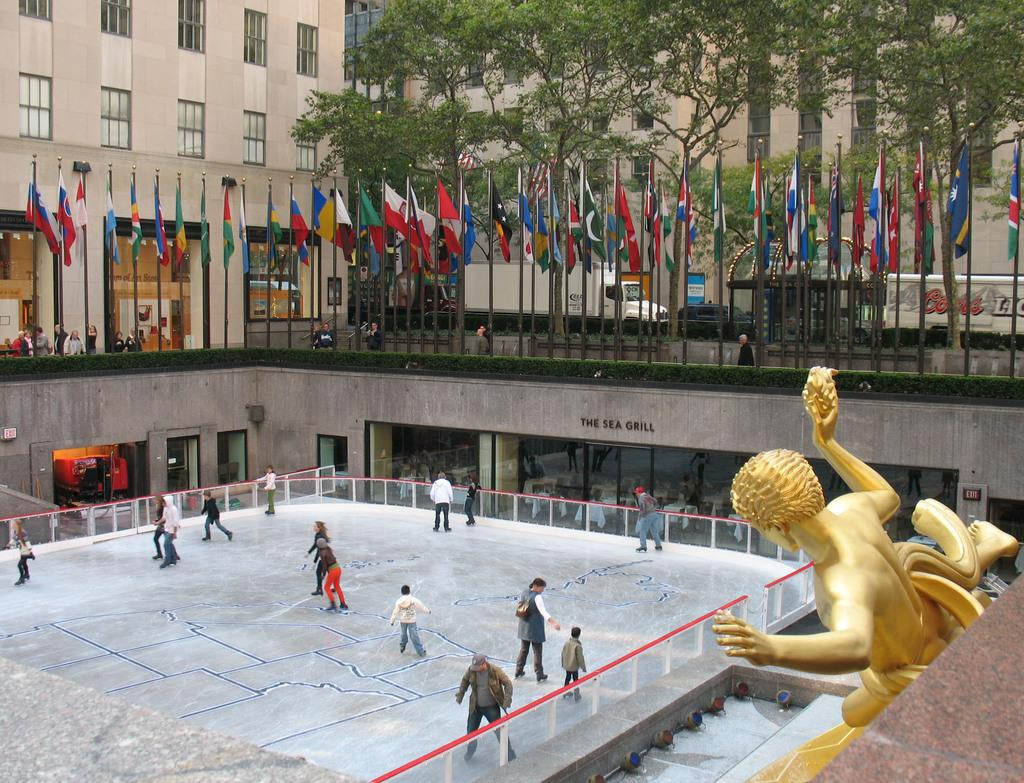Who or what can be seen in the image? There are people in the image. What is located on the right side of the image? There is a statue on the right side of the image. What can be seen flying in the image? There are flags visible in the image. What type of vegetation is present in the image? There are trees in the image. What type of transportation is present in the image? Vehicles are present in the image. What type of structures can be seen in the image? There are buildings in the image. What type of boat is visible in the image? There is no boat present in the image. What type of meeting is taking place in the image? There is no meeting taking place in the image. 